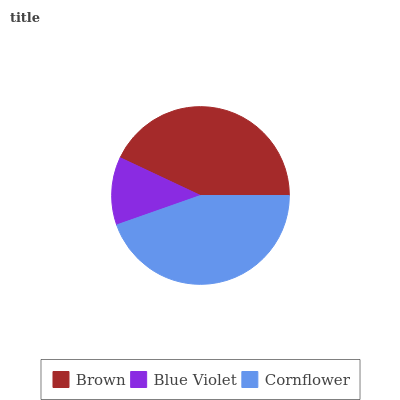Is Blue Violet the minimum?
Answer yes or no. Yes. Is Cornflower the maximum?
Answer yes or no. Yes. Is Cornflower the minimum?
Answer yes or no. No. Is Blue Violet the maximum?
Answer yes or no. No. Is Cornflower greater than Blue Violet?
Answer yes or no. Yes. Is Blue Violet less than Cornflower?
Answer yes or no. Yes. Is Blue Violet greater than Cornflower?
Answer yes or no. No. Is Cornflower less than Blue Violet?
Answer yes or no. No. Is Brown the high median?
Answer yes or no. Yes. Is Brown the low median?
Answer yes or no. Yes. Is Blue Violet the high median?
Answer yes or no. No. Is Blue Violet the low median?
Answer yes or no. No. 